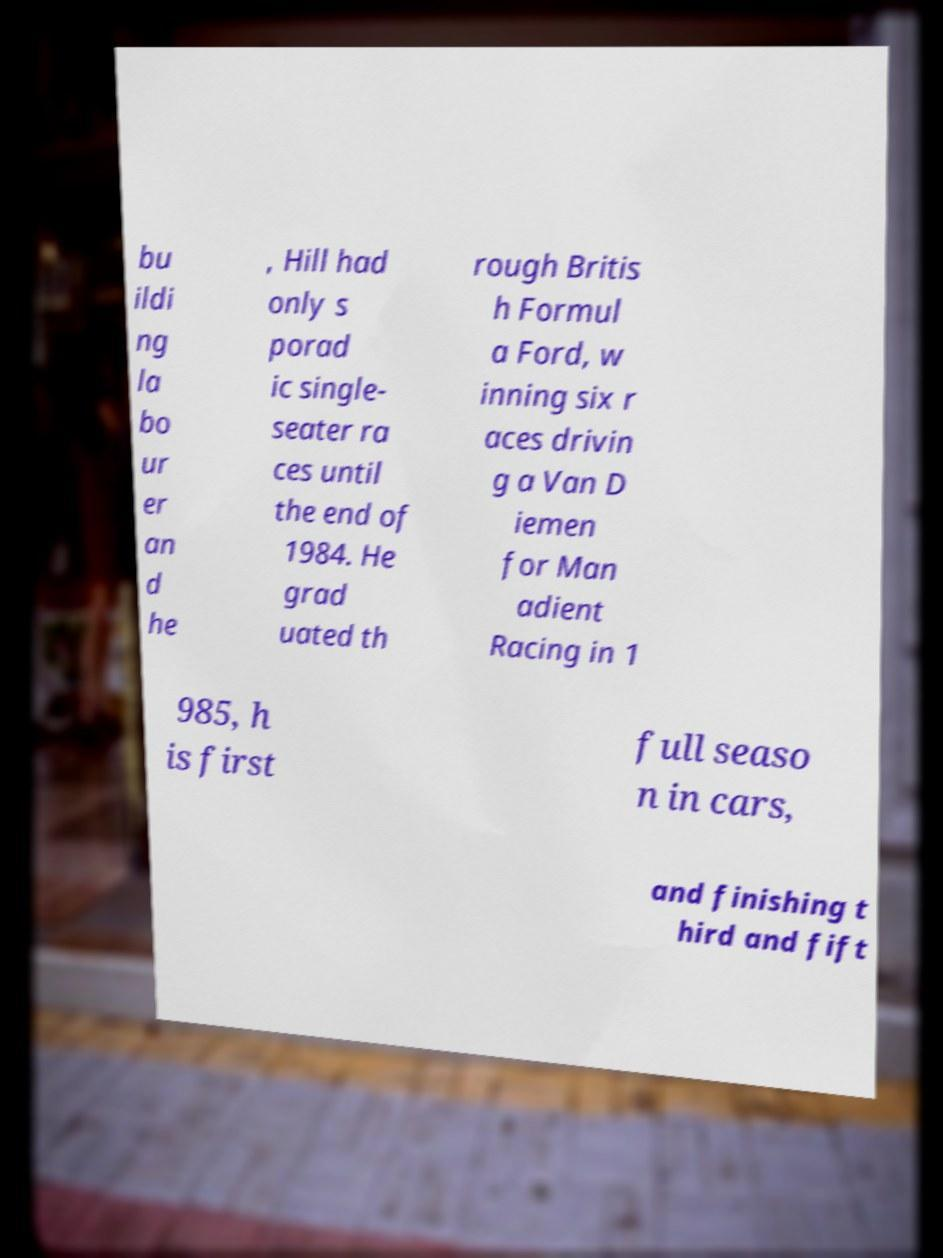What messages or text are displayed in this image? I need them in a readable, typed format. bu ildi ng la bo ur er an d he , Hill had only s porad ic single- seater ra ces until the end of 1984. He grad uated th rough Britis h Formul a Ford, w inning six r aces drivin g a Van D iemen for Man adient Racing in 1 985, h is first full seaso n in cars, and finishing t hird and fift 